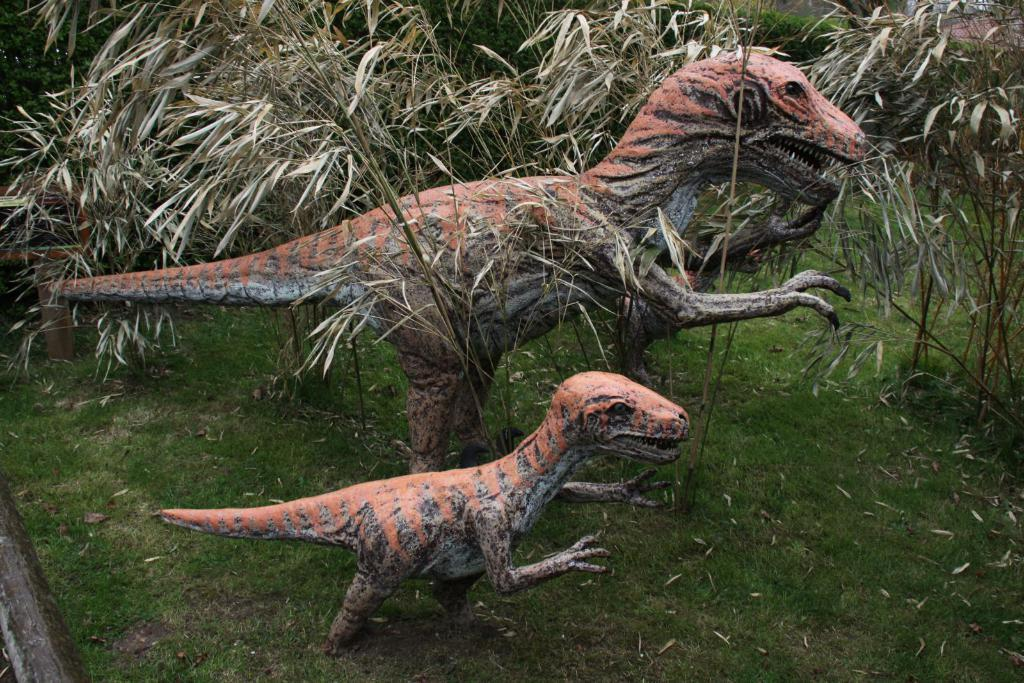What type of figures can be seen on the ground in the image? There are statues of dinosaurs on the ground. What can be seen in the background of the image? There are plants in the background of the image. What type of engine can be seen powering the dinosaur statues in the image? There is no engine present in the image; the dinosaur statues are stationary. What type of tin object is visible in the image? There is no tin object present in the image. 